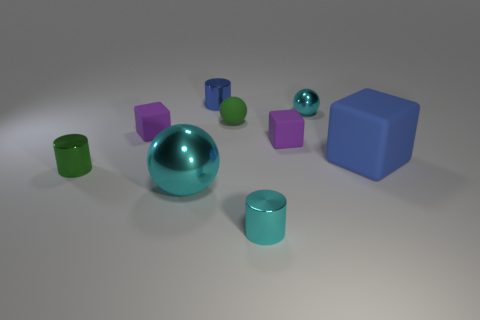What is the material of the tiny cylinder that is the same color as the large rubber thing?
Your answer should be very brief. Metal. There is a object that is to the right of the tiny blue metallic cylinder and left of the small cyan cylinder; how big is it?
Keep it short and to the point. Small. The tiny matte block to the right of the cyan sphere that is in front of the green ball is what color?
Provide a succinct answer. Purple. What number of brown objects are large balls or rubber blocks?
Offer a terse response. 0. What is the color of the tiny object that is both on the left side of the small blue object and in front of the large blue cube?
Offer a very short reply. Green. How many small things are cylinders or blue rubber objects?
Your answer should be compact. 3. What size is the other cyan metallic object that is the same shape as the large metal thing?
Your answer should be compact. Small. What is the shape of the large cyan thing?
Offer a terse response. Sphere. Are the small blue thing and the small block right of the tiny cyan shiny cylinder made of the same material?
Offer a terse response. No. How many rubber things are green balls or tiny cubes?
Ensure brevity in your answer.  3. 